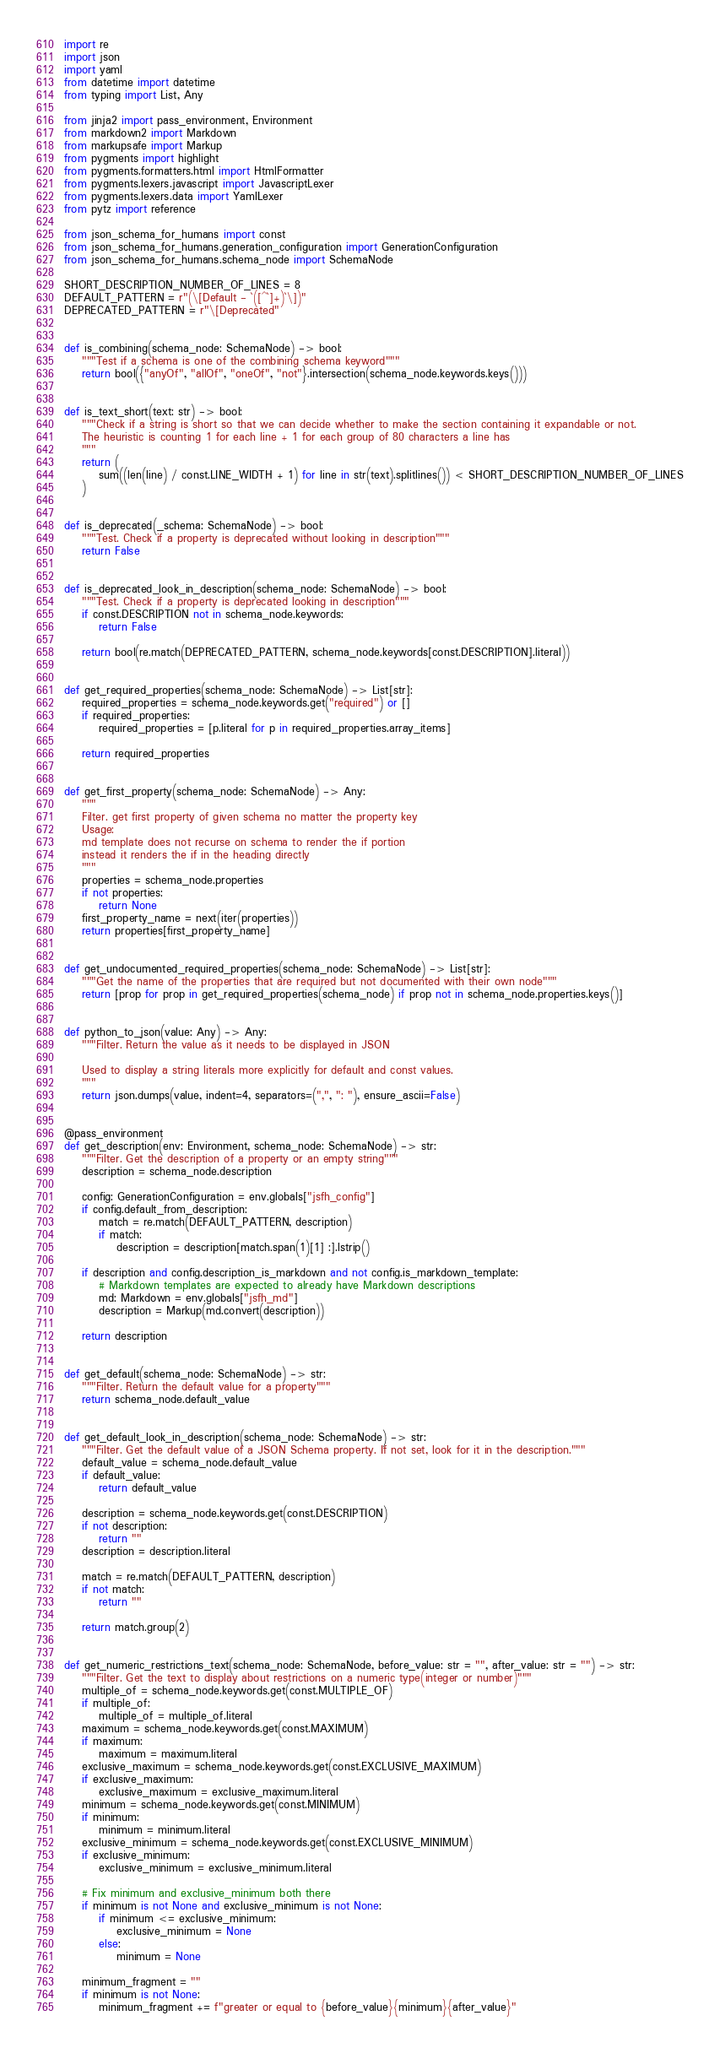Convert code to text. <code><loc_0><loc_0><loc_500><loc_500><_Python_>import re
import json
import yaml
from datetime import datetime
from typing import List, Any

from jinja2 import pass_environment, Environment
from markdown2 import Markdown
from markupsafe import Markup
from pygments import highlight
from pygments.formatters.html import HtmlFormatter
from pygments.lexers.javascript import JavascriptLexer
from pygments.lexers.data import YamlLexer
from pytz import reference

from json_schema_for_humans import const
from json_schema_for_humans.generation_configuration import GenerationConfiguration
from json_schema_for_humans.schema_node import SchemaNode

SHORT_DESCRIPTION_NUMBER_OF_LINES = 8
DEFAULT_PATTERN = r"(\[Default - `([^`]+)`\])"
DEPRECATED_PATTERN = r"\[Deprecated"


def is_combining(schema_node: SchemaNode) -> bool:
    """Test if a schema is one of the combining schema keyword"""
    return bool({"anyOf", "allOf", "oneOf", "not"}.intersection(schema_node.keywords.keys()))


def is_text_short(text: str) -> bool:
    """Check if a string is short so that we can decide whether to make the section containing it expandable or not.
    The heuristic is counting 1 for each line + 1 for each group of 80 characters a line has
    """
    return (
        sum((len(line) / const.LINE_WIDTH + 1) for line in str(text).splitlines()) < SHORT_DESCRIPTION_NUMBER_OF_LINES
    )


def is_deprecated(_schema: SchemaNode) -> bool:
    """Test. Check if a property is deprecated without looking in description"""
    return False


def is_deprecated_look_in_description(schema_node: SchemaNode) -> bool:
    """Test. Check if a property is deprecated looking in description"""
    if const.DESCRIPTION not in schema_node.keywords:
        return False

    return bool(re.match(DEPRECATED_PATTERN, schema_node.keywords[const.DESCRIPTION].literal))


def get_required_properties(schema_node: SchemaNode) -> List[str]:
    required_properties = schema_node.keywords.get("required") or []
    if required_properties:
        required_properties = [p.literal for p in required_properties.array_items]

    return required_properties


def get_first_property(schema_node: SchemaNode) -> Any:
    """
    Filter. get first property of given schema no matter the property key
    Usage:
    md template does not recurse on schema to render the if portion
    instead it renders the if in the heading directly
    """
    properties = schema_node.properties
    if not properties:
        return None
    first_property_name = next(iter(properties))
    return properties[first_property_name]


def get_undocumented_required_properties(schema_node: SchemaNode) -> List[str]:
    """Get the name of the properties that are required but not documented with their own node"""
    return [prop for prop in get_required_properties(schema_node) if prop not in schema_node.properties.keys()]


def python_to_json(value: Any) -> Any:
    """Filter. Return the value as it needs to be displayed in JSON

    Used to display a string literals more explicitly for default and const values.
    """
    return json.dumps(value, indent=4, separators=(",", ": "), ensure_ascii=False)


@pass_environment
def get_description(env: Environment, schema_node: SchemaNode) -> str:
    """Filter. Get the description of a property or an empty string"""
    description = schema_node.description

    config: GenerationConfiguration = env.globals["jsfh_config"]
    if config.default_from_description:
        match = re.match(DEFAULT_PATTERN, description)
        if match:
            description = description[match.span(1)[1] :].lstrip()

    if description and config.description_is_markdown and not config.is_markdown_template:
        # Markdown templates are expected to already have Markdown descriptions
        md: Markdown = env.globals["jsfh_md"]
        description = Markup(md.convert(description))

    return description


def get_default(schema_node: SchemaNode) -> str:
    """Filter. Return the default value for a property"""
    return schema_node.default_value


def get_default_look_in_description(schema_node: SchemaNode) -> str:
    """Filter. Get the default value of a JSON Schema property. If not set, look for it in the description."""
    default_value = schema_node.default_value
    if default_value:
        return default_value

    description = schema_node.keywords.get(const.DESCRIPTION)
    if not description:
        return ""
    description = description.literal

    match = re.match(DEFAULT_PATTERN, description)
    if not match:
        return ""

    return match.group(2)


def get_numeric_restrictions_text(schema_node: SchemaNode, before_value: str = "", after_value: str = "") -> str:
    """Filter. Get the text to display about restrictions on a numeric type(integer or number)"""
    multiple_of = schema_node.keywords.get(const.MULTIPLE_OF)
    if multiple_of:
        multiple_of = multiple_of.literal
    maximum = schema_node.keywords.get(const.MAXIMUM)
    if maximum:
        maximum = maximum.literal
    exclusive_maximum = schema_node.keywords.get(const.EXCLUSIVE_MAXIMUM)
    if exclusive_maximum:
        exclusive_maximum = exclusive_maximum.literal
    minimum = schema_node.keywords.get(const.MINIMUM)
    if minimum:
        minimum = minimum.literal
    exclusive_minimum = schema_node.keywords.get(const.EXCLUSIVE_MINIMUM)
    if exclusive_minimum:
        exclusive_minimum = exclusive_minimum.literal

    # Fix minimum and exclusive_minimum both there
    if minimum is not None and exclusive_minimum is not None:
        if minimum <= exclusive_minimum:
            exclusive_minimum = None
        else:
            minimum = None

    minimum_fragment = ""
    if minimum is not None:
        minimum_fragment += f"greater or equal to {before_value}{minimum}{after_value}"</code> 